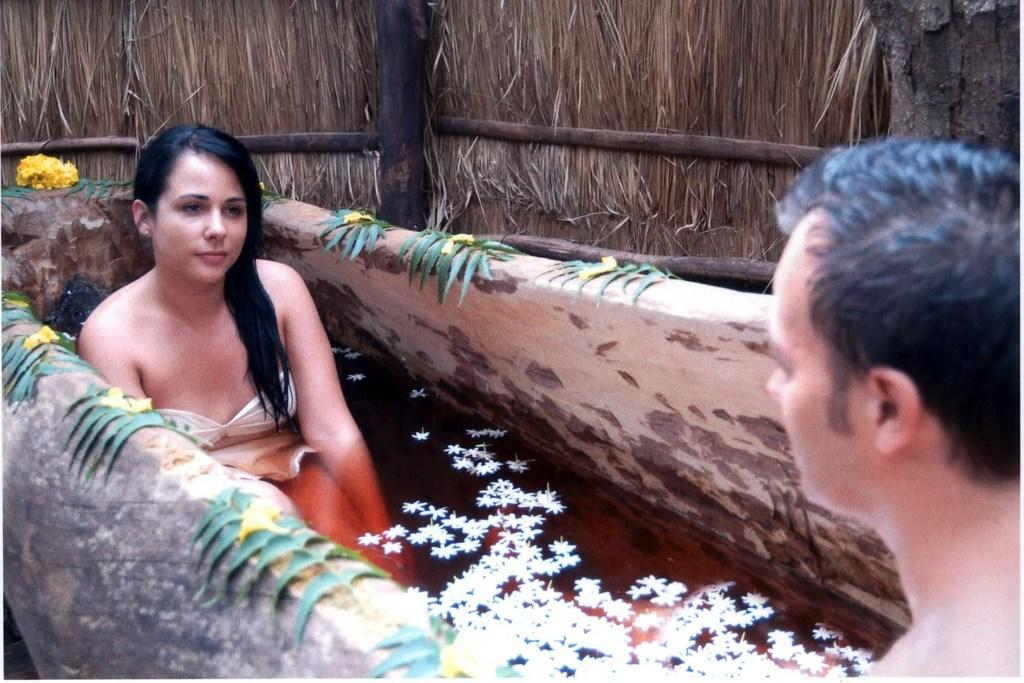Who or what can be seen in the image? There are people in the image. What else is present in the image besides people? There are flowers, leaves, wooden sticks, and dry grass in the image. Can you describe the wooden sticks be used for any specific purpose in the image? The purpose of the wooden sticks in the image is not specified, but they could be used for various purposes such as support or decoration. What type of natural environment is depicted in the image? The image features flowers, leaves, and dry grass, which suggests a natural environment. What type of haircut does the person in the image have? There is no person in the image with a haircut; the image features flowers, leaves, wooden sticks, and dry grass. What property is being sold in the image? There is no property being sold in the image; the image features flowers, leaves, wooden sticks, and dry grass. 